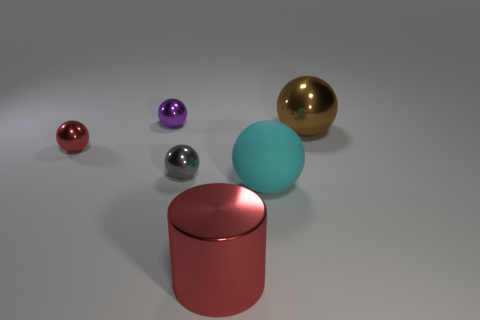What material is the big cyan object that is the same shape as the large brown shiny thing?
Your answer should be very brief. Rubber. What color is the metallic cylinder?
Make the answer very short. Red. What number of rubber things are red spheres or big brown objects?
Your response must be concise. 0. There is a tiny ball to the left of the thing that is behind the brown metal thing; are there any gray objects that are right of it?
Offer a very short reply. Yes. There is a brown thing that is the same material as the cylinder; what size is it?
Provide a succinct answer. Large. There is a red cylinder; are there any small gray metal spheres behind it?
Ensure brevity in your answer.  Yes. There is a big shiny object that is in front of the tiny gray metallic ball; are there any tiny gray balls in front of it?
Provide a succinct answer. No. Does the metal thing right of the large rubber thing have the same size as the red thing in front of the large cyan thing?
Your response must be concise. Yes. How many large objects are red metallic cylinders or spheres?
Ensure brevity in your answer.  3. What is the big sphere that is in front of the tiny red sphere in front of the brown sphere made of?
Your answer should be compact. Rubber. 